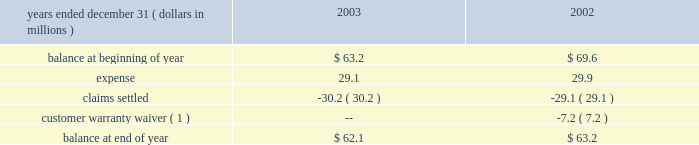Contracts and customer purchase orders are generally used to determine the existence of an arrangement .
Shipping documents are used to verify delivery .
The company assesses whether the selling price is fixed or determinable based upon the payment terms associated with the transaction and whether the sales price is subject to refund or adjustment .
The company assesses collectibility based primarily on the creditworthiness of the customer as determined by credit checks and analysis , as well as the customer 2019s payment history .
Accruals for customer returns for defective product are based on historical experience with similar types of sales .
Accruals for rebates and incentives are based on pricing agreements and are generally tied to sales volume .
Changes in such accruals may be required if future returns differ from historical experience or if actual sales volume differ from estimated sales volume .
Rebates and incentives are recognized as a reduction of sales .
Compensated absences .
In the fourth quarter of 2001 , the company changed its vacation policy for certain employees so that vacation pay is earned ratably throughout the year and must be used by year-end .
The accrual for compensated absences was reduced by $ 1.6 million in 2001 to eliminate vacation pay no longer required to be accrued under the current policy .
Advertising .
Advertising costs are charged to operations as incurred and amounted to $ 18.4 , $ 16.2 and $ 8.8 million during 2003 , 2002 and 2001 respectively .
Research and development .
Research and development costs are charged to operations as incurred and amounted to $ 34.6 , $ 30.4 and $ 27.6 million during 2003 , 2002 and 2001 , respectively .
Product warranty .
The company 2019s products carry warranties that generally range from one to six years and are based on terms that are generally accepted in the market place .
The company records a liability for the expected cost of warranty-related claims at the time of sale .
The allocation of our warranty liability between current and long-term is based on expected warranty claims to be paid in the next year as determined by historical product failure rates .
Organization and significant accounting policies ( continued ) the table presents the company 2019s product warranty liability activity in 2003 and 2002 : note to table : environmental costs .
The company accrues for losses associated with environmental obligations when such losses are probable and reasonably estimable .
Costs of estimated future expenditures are not discounted to their present value .
Recoveries of environmental costs from other parties are recorded as assets when their receipt is considered probable .
The accruals are adjusted as facts and circumstances change .
Stock based compensation .
The company has one stock-based employee compensation plan ( see note 11 ) .
Sfas no .
123 , 201caccounting for stock-based compensation , 201d encourages , but does not require companies to record compensation cost for stock-based employee compensation plans at fair value .
The company has chosen to continue applying accounting principles board opinion no .
25 , 201caccounting for stock issued to employees , 201d and related interpretations , in accounting for its stock option plans .
Accordingly , because the number of shares is fixed and the exercise price of the stock options equals the market price of the underlying stock on the date of grant , no compensation expense has been recognized .
Had compensation cost been determined based upon the fair value at the grant date for awards under the plans based on the provisions of sfas no .
123 , the company 2019s pro forma earnings and earnings per share would have been as follows: .
( 1 ) in exchange for other concessions , the customer has agreed to accept responsibility for units they have purchased from the company which become defective .
The amount of the warranty reserve applicable to the estimated number of units previously sold to this customer that may become defective has been reclassified from the product warranty liability to a deferred revenue account. .
What was the percentage change in research and development costs between 2001 and 2002? 
Computations: ((30.4 - 27.6) / 27.6)
Answer: 0.10145. 